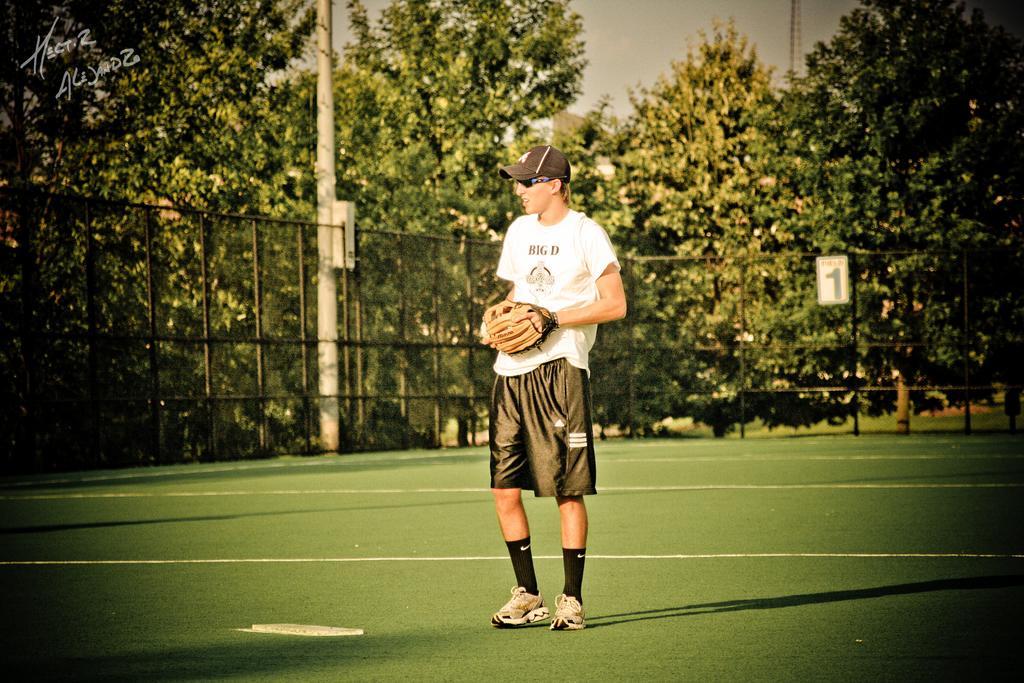Describe this image in one or two sentences. In this image a man is standing on the ground wearing cap, sunglasses and white t-shirt. In the background there are trees, pole. There is boundary around the ground. 